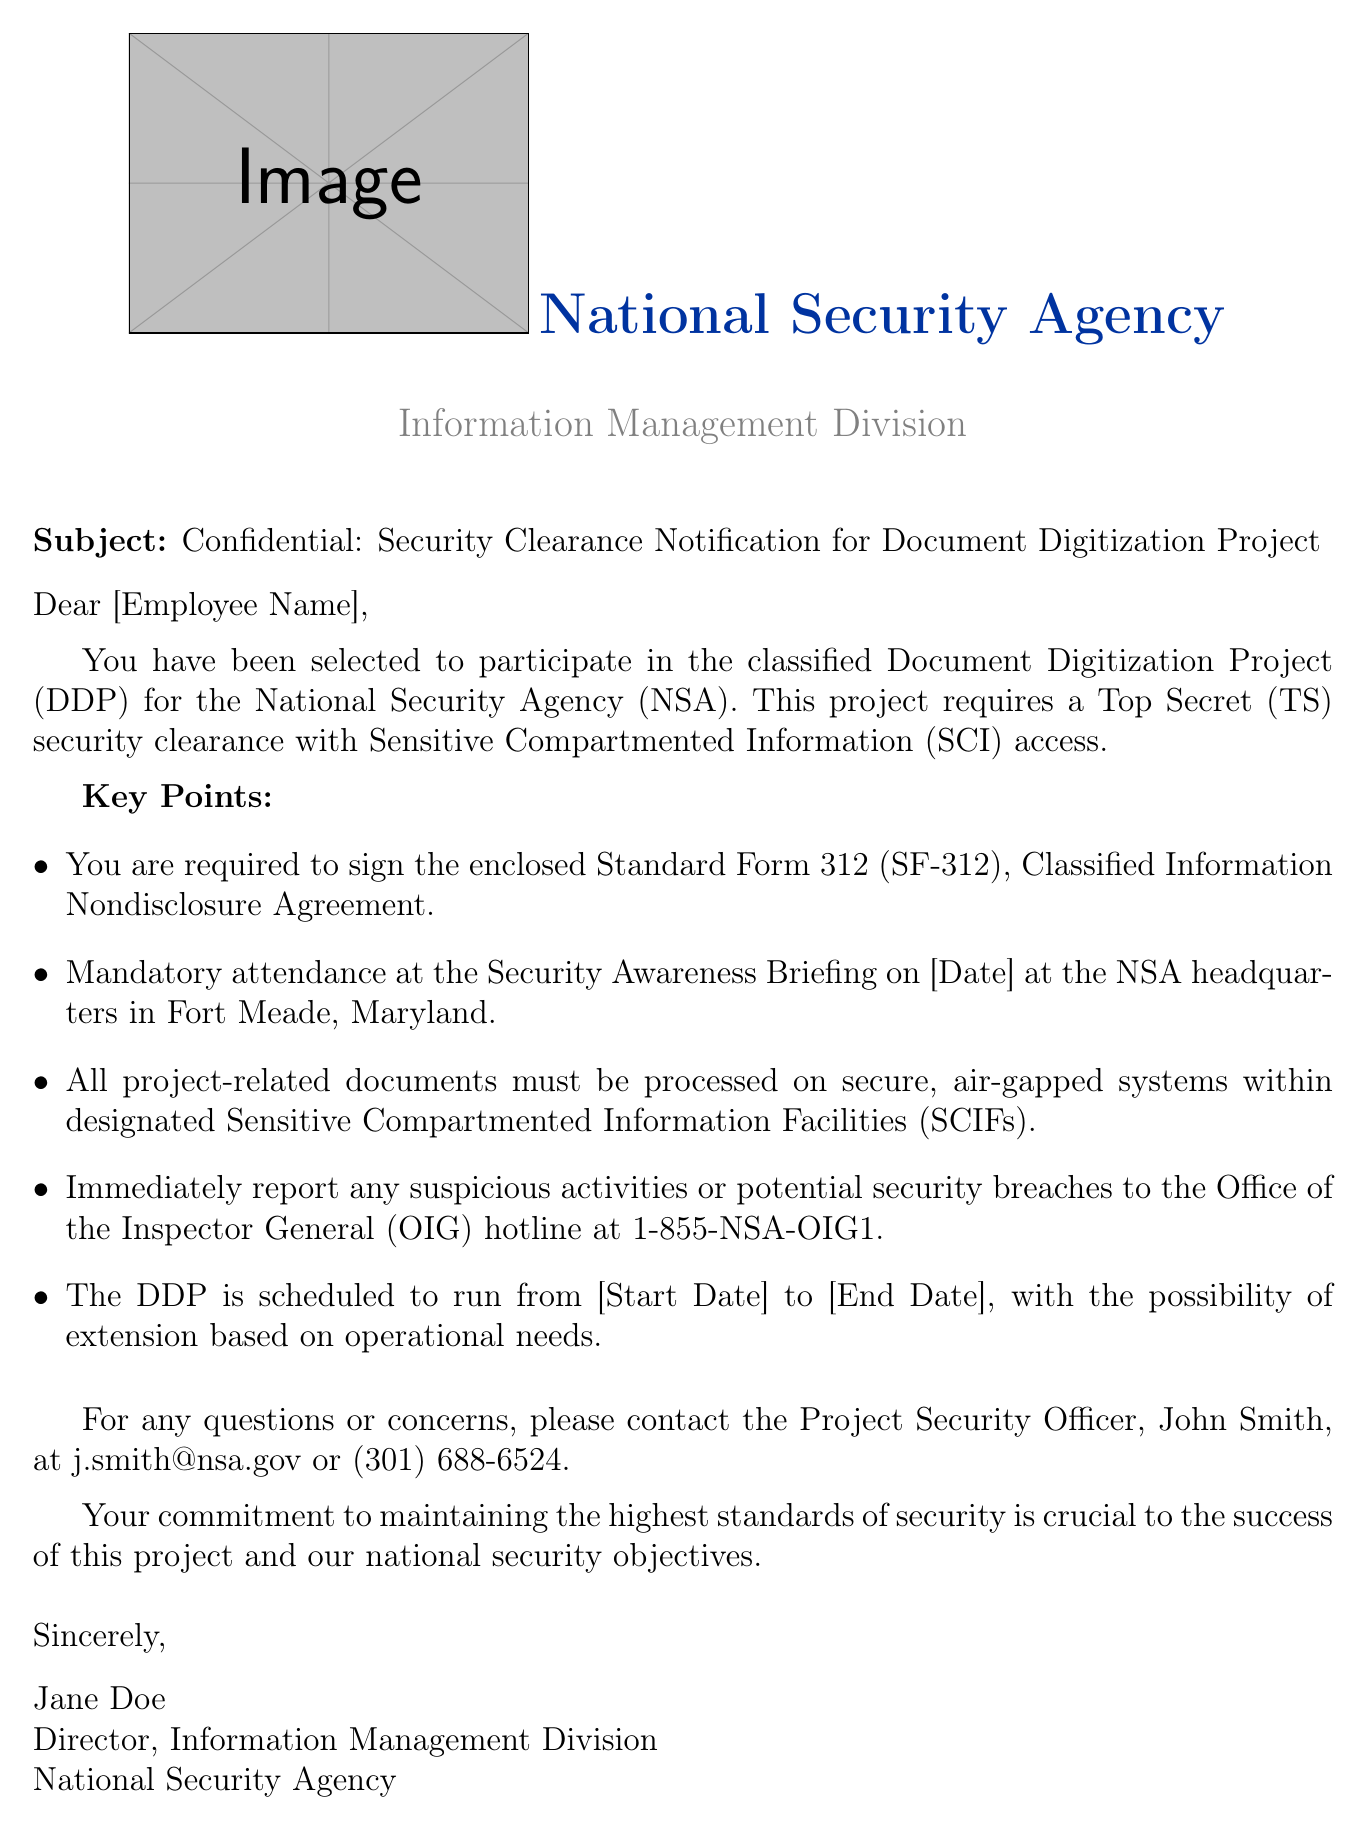What is the subject of the email? The subject of the email is stated at the top and indicates the main focus of the communication.
Answer: Confidential: Security Clearance Notification for Document Digitization Project Who is the sender of the email? The sender is specified in the closing section of the document, where the name and title are provided.
Answer: Jane Doe What security clearance is required for the project? The document explicitly mentions the required security clearance level for participation in the project.
Answer: Top Secret (TS) What must the employee sign to participate in the project? The text outlines a mandatory requirement for the employee before they can engage in the project.
Answer: Standard Form 312 (SF-312) Where is the Security Awareness Briefing held? The document indicates the location where the mandatory briefing will take place.
Answer: NSA headquarters in Fort Meade, Maryland What should be done with suspicious activities? The document specifies the action to take when encountering suspicious situations during the project.
Answer: Report to the Office of the Inspector General (OIG) hotline What is the project duration? The duration of the project is mentioned, including potential start and end dates, although placeholders are used in the document itself.
Answer: Scheduled to run from [Start Date] to [End Date] Who is the point of contact for questions regarding the project? The email provides specific contact information for addressing any concerns or inquiries related to the project.
Answer: John Smith When is the Security Awareness Briefing scheduled? The document outlines a required brief but places a placeholder for the specific date.
Answer: [Date] 